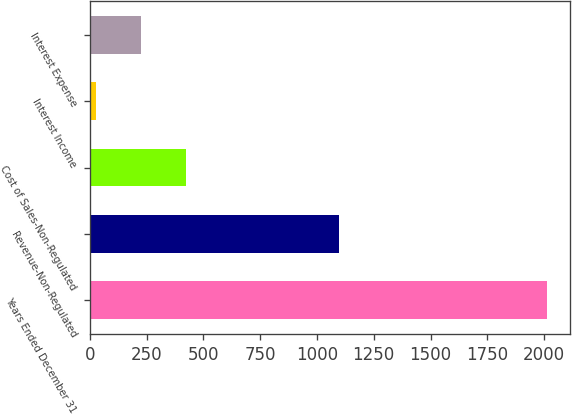Convert chart to OTSL. <chart><loc_0><loc_0><loc_500><loc_500><bar_chart><fcel>Years Ended December 31<fcel>Revenue-Non-Regulated<fcel>Cost of Sales-Non-Regulated<fcel>Interest Income<fcel>Interest Expense<nl><fcel>2015<fcel>1099<fcel>423<fcel>25<fcel>224<nl></chart> 